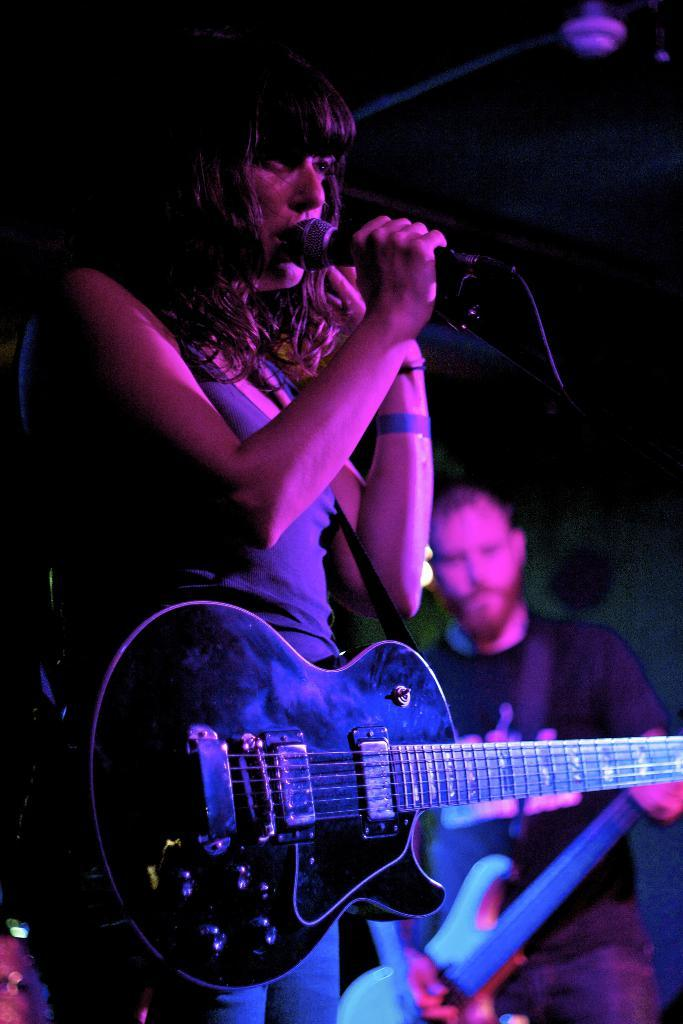Who is the main subject in the center of the image? There is a lady in the center of the image. What is the lady holding in her hands? The lady is holding a microphone and a guitar. Who else is present in the image? There is a man on the right side of the image. What is the man holding in his hands? The man is holding a guitar. How many bottles of soda are visible on the stage in the image? There is no mention of soda bottles in the image; the main subjects are the lady and the man holding guitars and a microphone. 